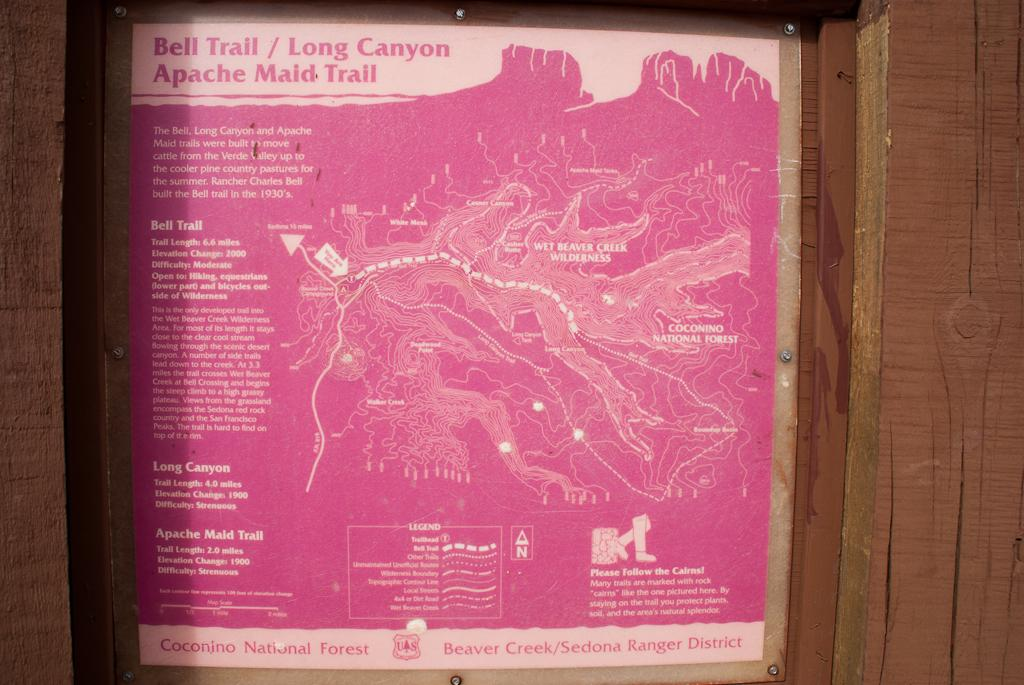<image>
Describe the image concisely. A pink colored map of a trail is in a wooden post structure. 